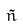<formula> <loc_0><loc_0><loc_500><loc_500>\tilde { n }</formula> 